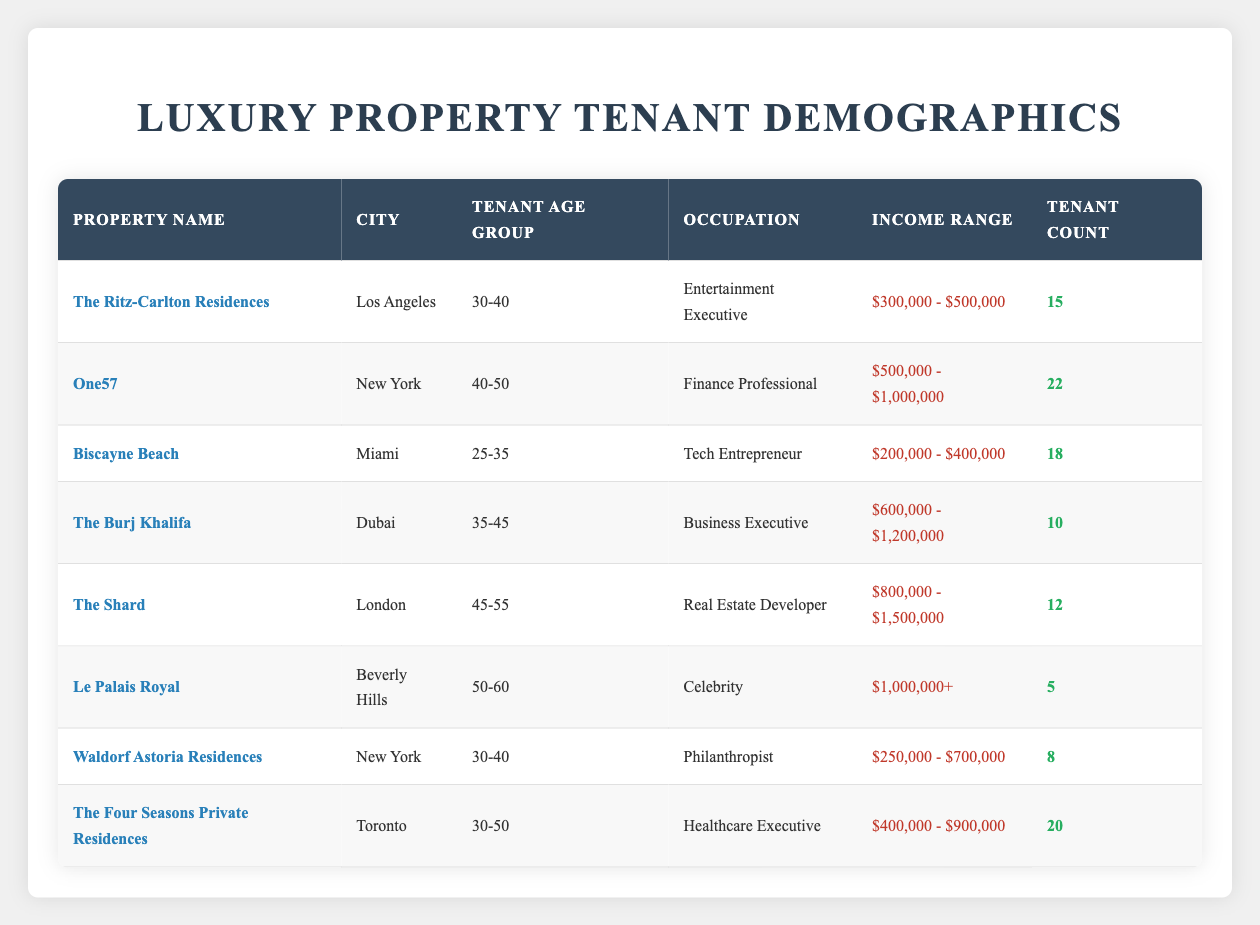What is the total tenant count for properties in New York? There are two properties listed in New York: One57 with a tenant count of 22 and Waldorf Astoria Residences with a tenant count of 8. Adding these counts together gives: 22 + 8 = 30.
Answer: 30 What is the occupation of tenants living in The Shard? The Shard has a tenant whose occupation is "Real Estate Developer". This information is directly available in the table.
Answer: Real Estate Developer Which property has the highest tenant count? By comparing the tenant counts from all properties: The highest count is found at One57 with a tenant count of 22.
Answer: One57 Are there any tenants aged 50-60 living in Miami? The table indicates that no properties in Miami have tenants in the age group of 50-60. Therefore, the answer is no.
Answer: No What is the average tenant count across the properties listed? To find the average, we first sum the tenant counts: 15 + 22 + 18 + 10 + 12 + 5 + 8 + 20 = 110. There are 8 properties, so the average is calculated as 110 / 8 = 13.75.
Answer: 13.75 How many tenants are in the income range of $200,000 - $400,000? The property Biscayne Beach has tenants in this income range with a tenant count of 18. This is the only property in this specific range.
Answer: 18 Which city has the least number of tenants? After inspecting the tenant counts for each city, Beverly Hills has the least tenant count at 5 from the property Le Palais Royal.
Answer: Beverly Hills Is there a property with tenants earning over $1,000,000? Yes, Le Palais Royal has tenants with an income range of $1,000,000 or more. Therefore, the answer is yes.
Answer: Yes What is the combined tenant count for age groups 30-40 across properties? The properties with age group 30-40 are The Ritz-Carlton Residences (15 tenants) and Waldorf Astoria Residences (8 tenants). Combining these gives: 15 + 8 = 23.
Answer: 23 